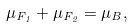<formula> <loc_0><loc_0><loc_500><loc_500>\mu _ { F _ { 1 } } + \mu _ { F _ { 2 } } = \mu _ { B } ,</formula> 